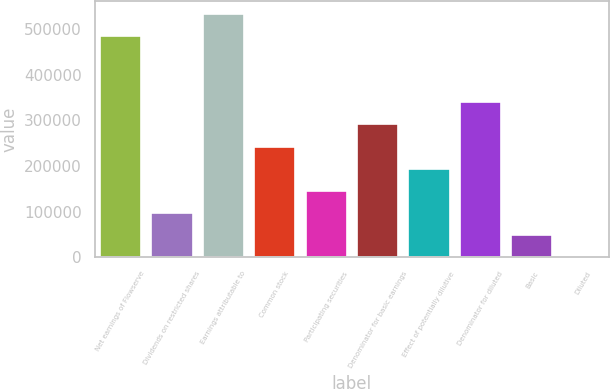Convert chart to OTSL. <chart><loc_0><loc_0><loc_500><loc_500><bar_chart><fcel>Net earnings of Flowserve<fcel>Dividends on restricted shares<fcel>Earnings attributable to<fcel>Common stock<fcel>Participating securities<fcel>Denominator for basic earnings<fcel>Effect of potentially dilutive<fcel>Denominator for diluted<fcel>Basic<fcel>Diluted<nl><fcel>485530<fcel>97111.3<fcel>534084<fcel>242773<fcel>145665<fcel>291327<fcel>194219<fcel>339881<fcel>48557.4<fcel>3.41<nl></chart> 